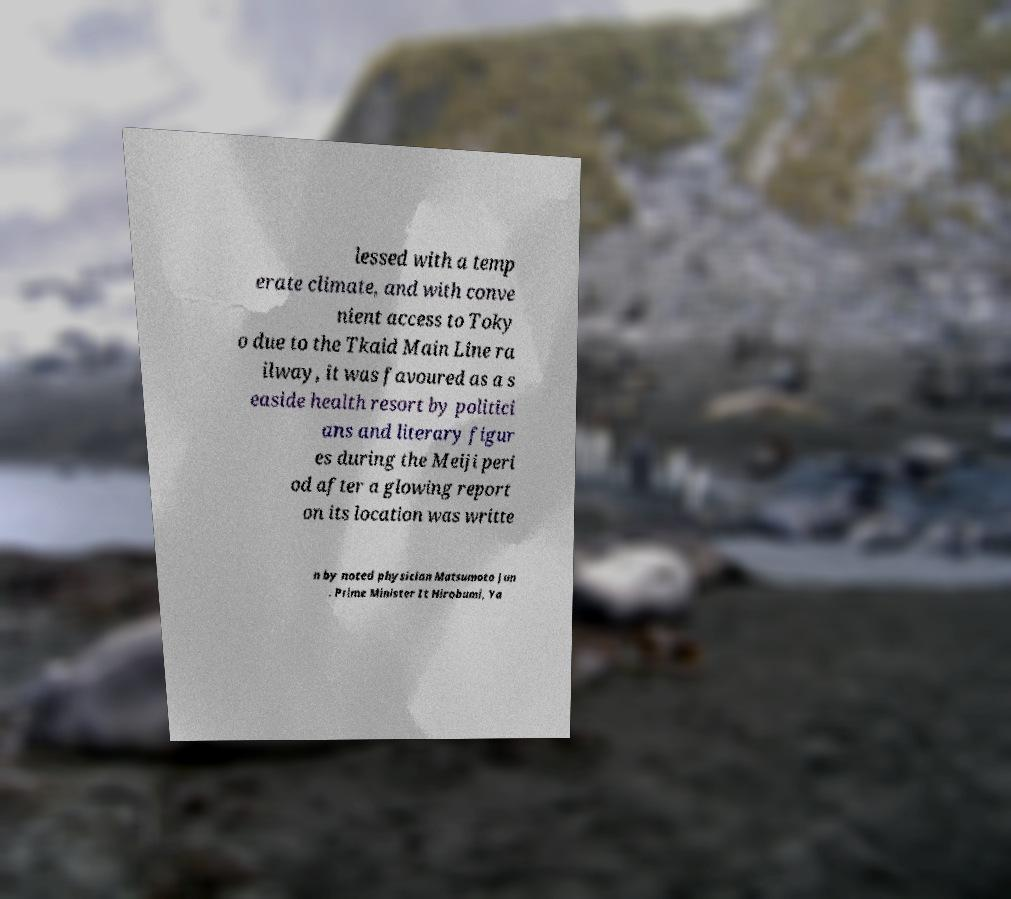Could you assist in decoding the text presented in this image and type it out clearly? lessed with a temp erate climate, and with conve nient access to Toky o due to the Tkaid Main Line ra ilway, it was favoured as a s easide health resort by politici ans and literary figur es during the Meiji peri od after a glowing report on its location was writte n by noted physician Matsumoto Jun . Prime Minister It Hirobumi, Ya 